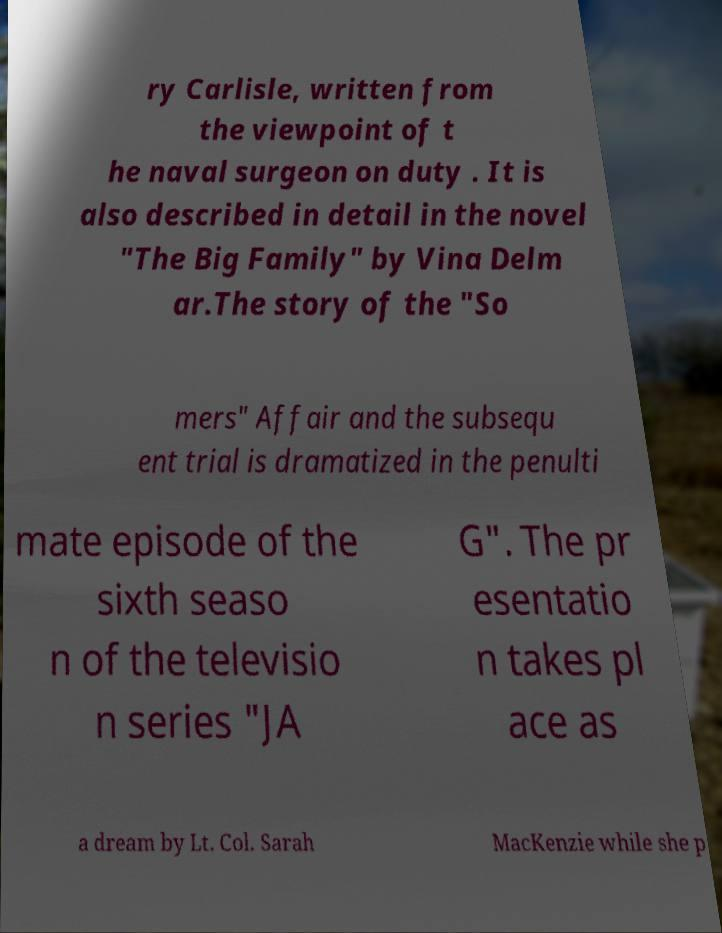What messages or text are displayed in this image? I need them in a readable, typed format. ry Carlisle, written from the viewpoint of t he naval surgeon on duty . It is also described in detail in the novel "The Big Family" by Vina Delm ar.The story of the "So mers" Affair and the subsequ ent trial is dramatized in the penulti mate episode of the sixth seaso n of the televisio n series "JA G". The pr esentatio n takes pl ace as a dream by Lt. Col. Sarah MacKenzie while she p 